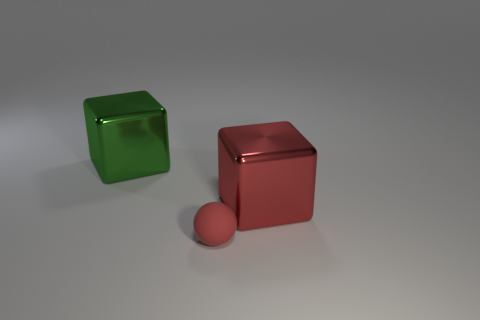What material do the objects in the image seem to be made of? The objects in the image appear to be made of a glass-like material for the green cube, as indicated by its transparency and reflections, and a more opaque, possibly metallic material for the red cube and sphere, suggested by their shininess and the way they reflect light. 